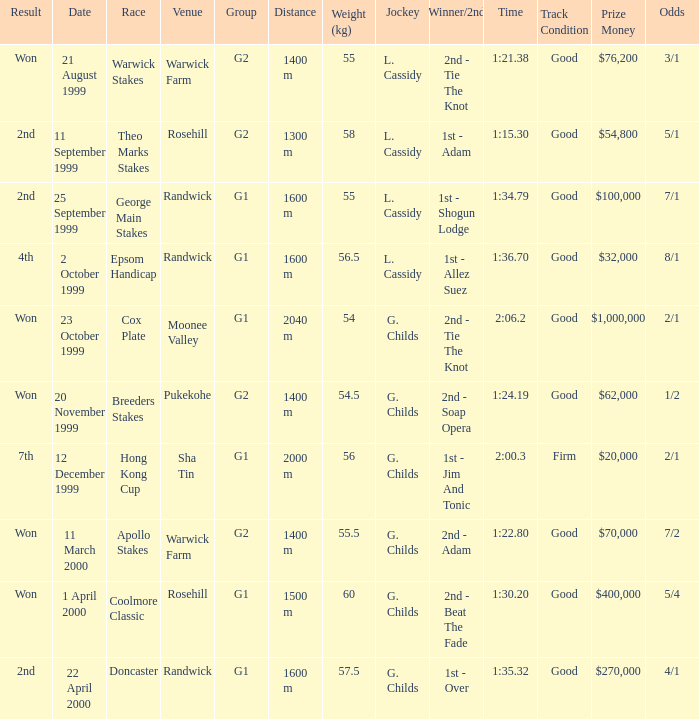How man teams had a total weight of 57.5? 1.0. 